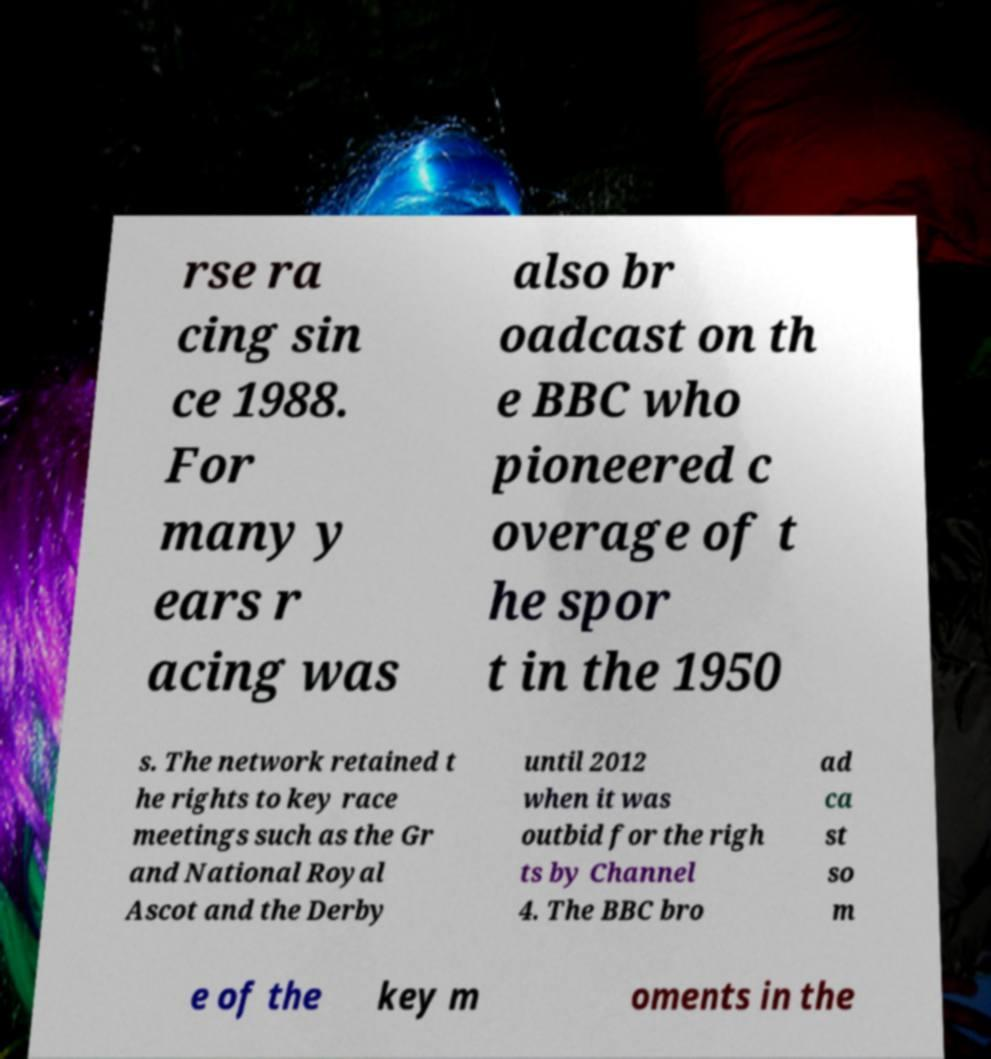Could you extract and type out the text from this image? rse ra cing sin ce 1988. For many y ears r acing was also br oadcast on th e BBC who pioneered c overage of t he spor t in the 1950 s. The network retained t he rights to key race meetings such as the Gr and National Royal Ascot and the Derby until 2012 when it was outbid for the righ ts by Channel 4. The BBC bro ad ca st so m e of the key m oments in the 